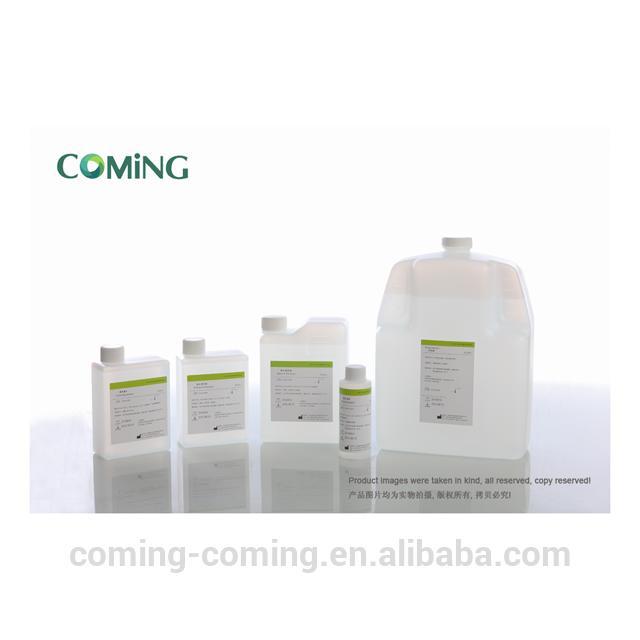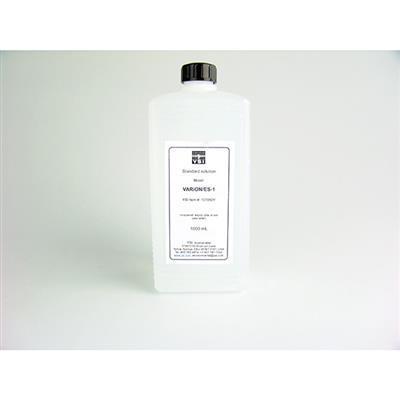The first image is the image on the left, the second image is the image on the right. For the images shown, is this caption "At least one image only has one bottle." true? Answer yes or no. Yes. 